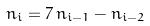<formula> <loc_0><loc_0><loc_500><loc_500>n _ { i } = 7 \, n _ { i - 1 } - n _ { i - 2 }</formula> 